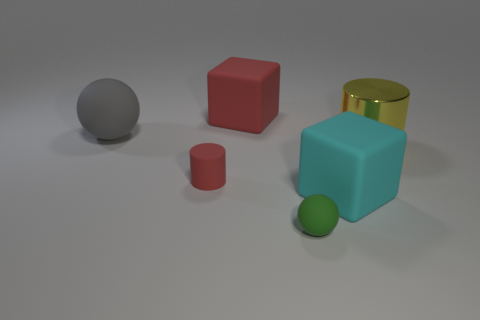Is the color of the rubber ball that is behind the green thing the same as the big metal cylinder?
Make the answer very short. No. What number of things are either big matte objects behind the small red rubber thing or green objects?
Your answer should be compact. 3. Are there more large cylinders that are in front of the green matte sphere than things to the right of the gray object?
Your response must be concise. No. Is the gray ball made of the same material as the yellow thing?
Ensure brevity in your answer.  No. What shape is the matte thing that is in front of the metal thing and to the left of the small green sphere?
Make the answer very short. Cylinder. What is the shape of the tiny green thing that is the same material as the gray ball?
Provide a succinct answer. Sphere. Are any yellow things visible?
Provide a succinct answer. Yes. Are there any shiny cylinders that are behind the matte block that is behind the big gray matte ball?
Provide a succinct answer. No. There is another thing that is the same shape as the cyan thing; what material is it?
Your response must be concise. Rubber. Is the number of yellow objects greater than the number of matte objects?
Provide a short and direct response. No. 